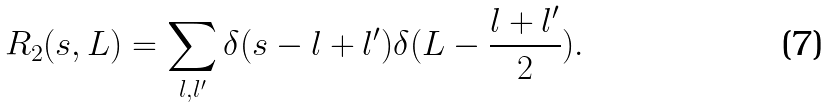Convert formula to latex. <formula><loc_0><loc_0><loc_500><loc_500>R _ { 2 } ( s , L ) = \sum _ { l , l ^ { \prime } } \delta ( s - l + l ^ { \prime } ) \delta ( L - \frac { l + l ^ { \prime } } { 2 } ) .</formula> 